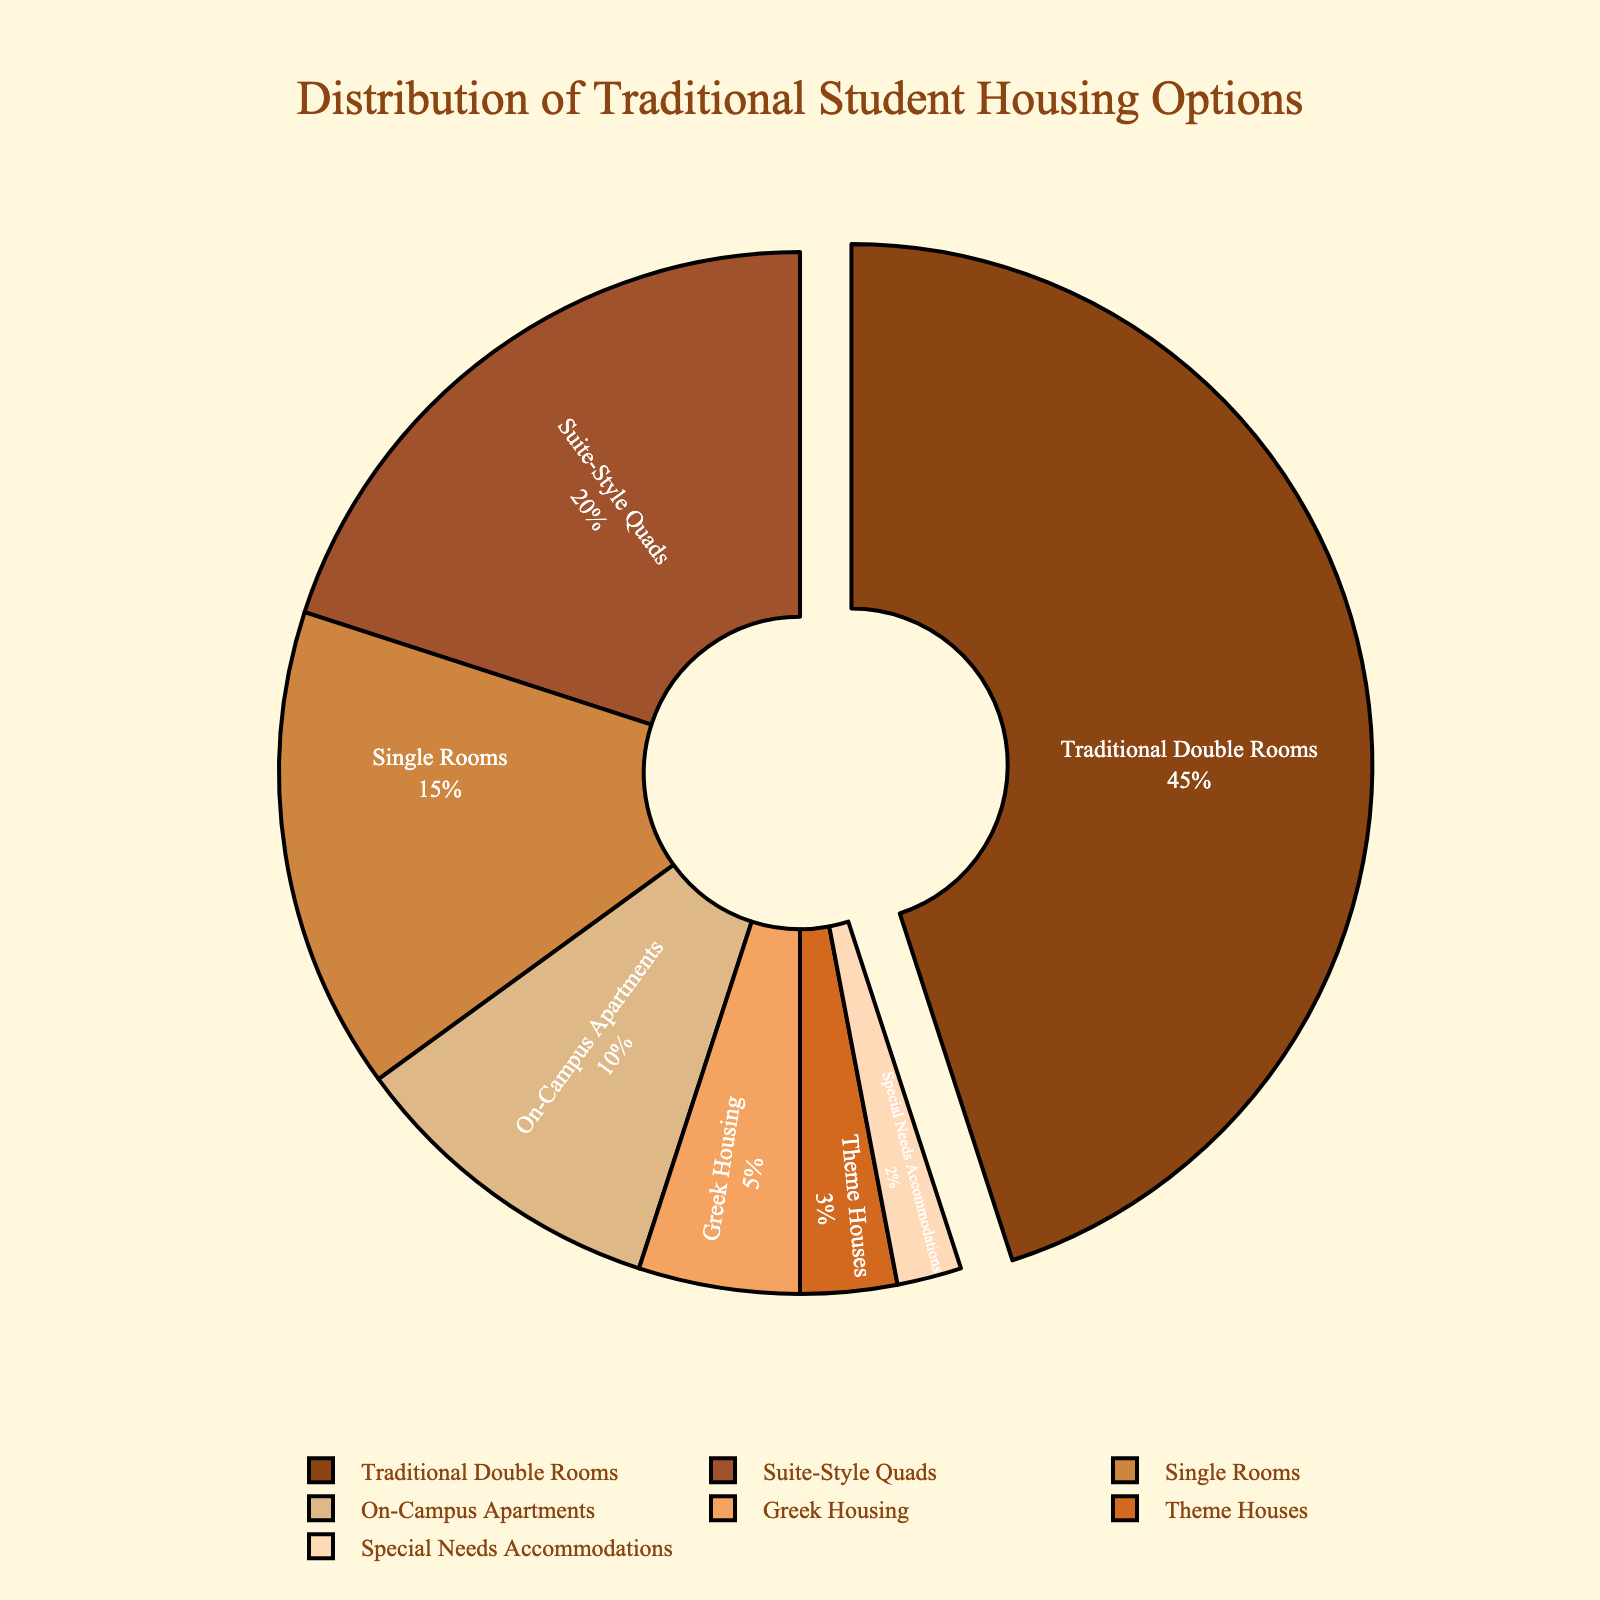What percentage of student housing is provided by Traditional Double Rooms compared to Greek Housing? Traditional Double Rooms have 45% and Greek Housing has 5%. To compare, we subtract Greek Housing percentage from Traditional Double Rooms percentage: 45% - 5% = 40%.
Answer: 40% Which housing type has the smallest percentage? By looking at the percentages listed in the figure, we see that Special Needs Accommodations has the smallest percentage at 2%.
Answer: Special Needs Accommodations What is the combined percentage of Suite-Style Quads, On-Campus Apartments, and Theme Houses? Suite-Style Quads have 20%, On-Campus Apartments have 10%, and Theme Houses have 3%. Adding these together: 20% + 10% + 3% = 33%.
Answer: 33% Are there more Single Rooms or Suite-Style Quads available on campus? Single Rooms have 15% while Suite-Style Quads have 20%. Comparing these, Suite-Style Quads have a higher percentage.
Answer: Suite-Style Quads What is the difference in percentage between Traditional Double Rooms and the next highest category? Traditional Double Rooms are at 45%, and the next highest category is Suite-Style Quads at 20%. The difference is 45% - 20% = 25%.
Answer: 25% Looking at the visual colors, which housing type is depicted in the lightest shade? The lightest shade is used for Special Needs Accommodations.
Answer: Special Needs Accommodations How many of the housing types have a percentage less than 10%? From the figure, the housing types with less than 10% are On-Campus Apartments (10%), Greek Housing (5%), Theme Houses (3%), and Special Needs Accommodations (2%). There are a total of 4 types.
Answer: 4 If the percentages of Single Rooms and On-Campus Apartments are combined, do they surpass the percentage of Traditional Double Rooms? Single Rooms have 15% and On-Campus Apartments have 10%. Combined, they equal 15% + 10% = 25%, which is less than 45% for Traditional Double Rooms. Therefore, they do not surpass it.
Answer: No What percentage of the housing types comprise traditional dormitory arrangements (Traditional Double Rooms, Suite-Style Quads, Single Rooms)? Adding the percentages of Traditional Double Rooms (45%), Suite-Style Quads (20%), and Single Rooms (15%) gives 45% + 20% + 15% = 80%.
Answer: 80% 